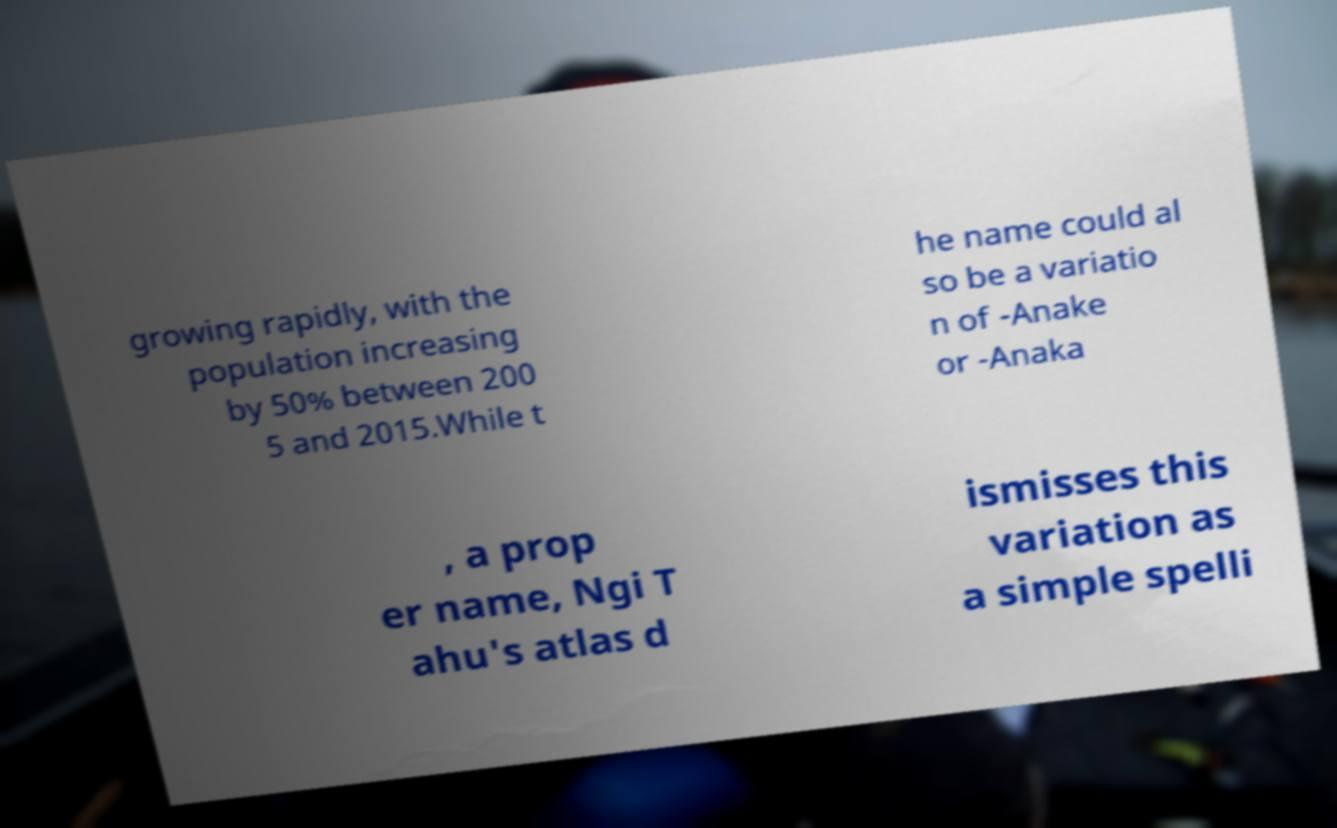What messages or text are displayed in this image? I need them in a readable, typed format. growing rapidly, with the population increasing by 50% between 200 5 and 2015.While t he name could al so be a variatio n of -Anake or -Anaka , a prop er name, Ngi T ahu's atlas d ismisses this variation as a simple spelli 